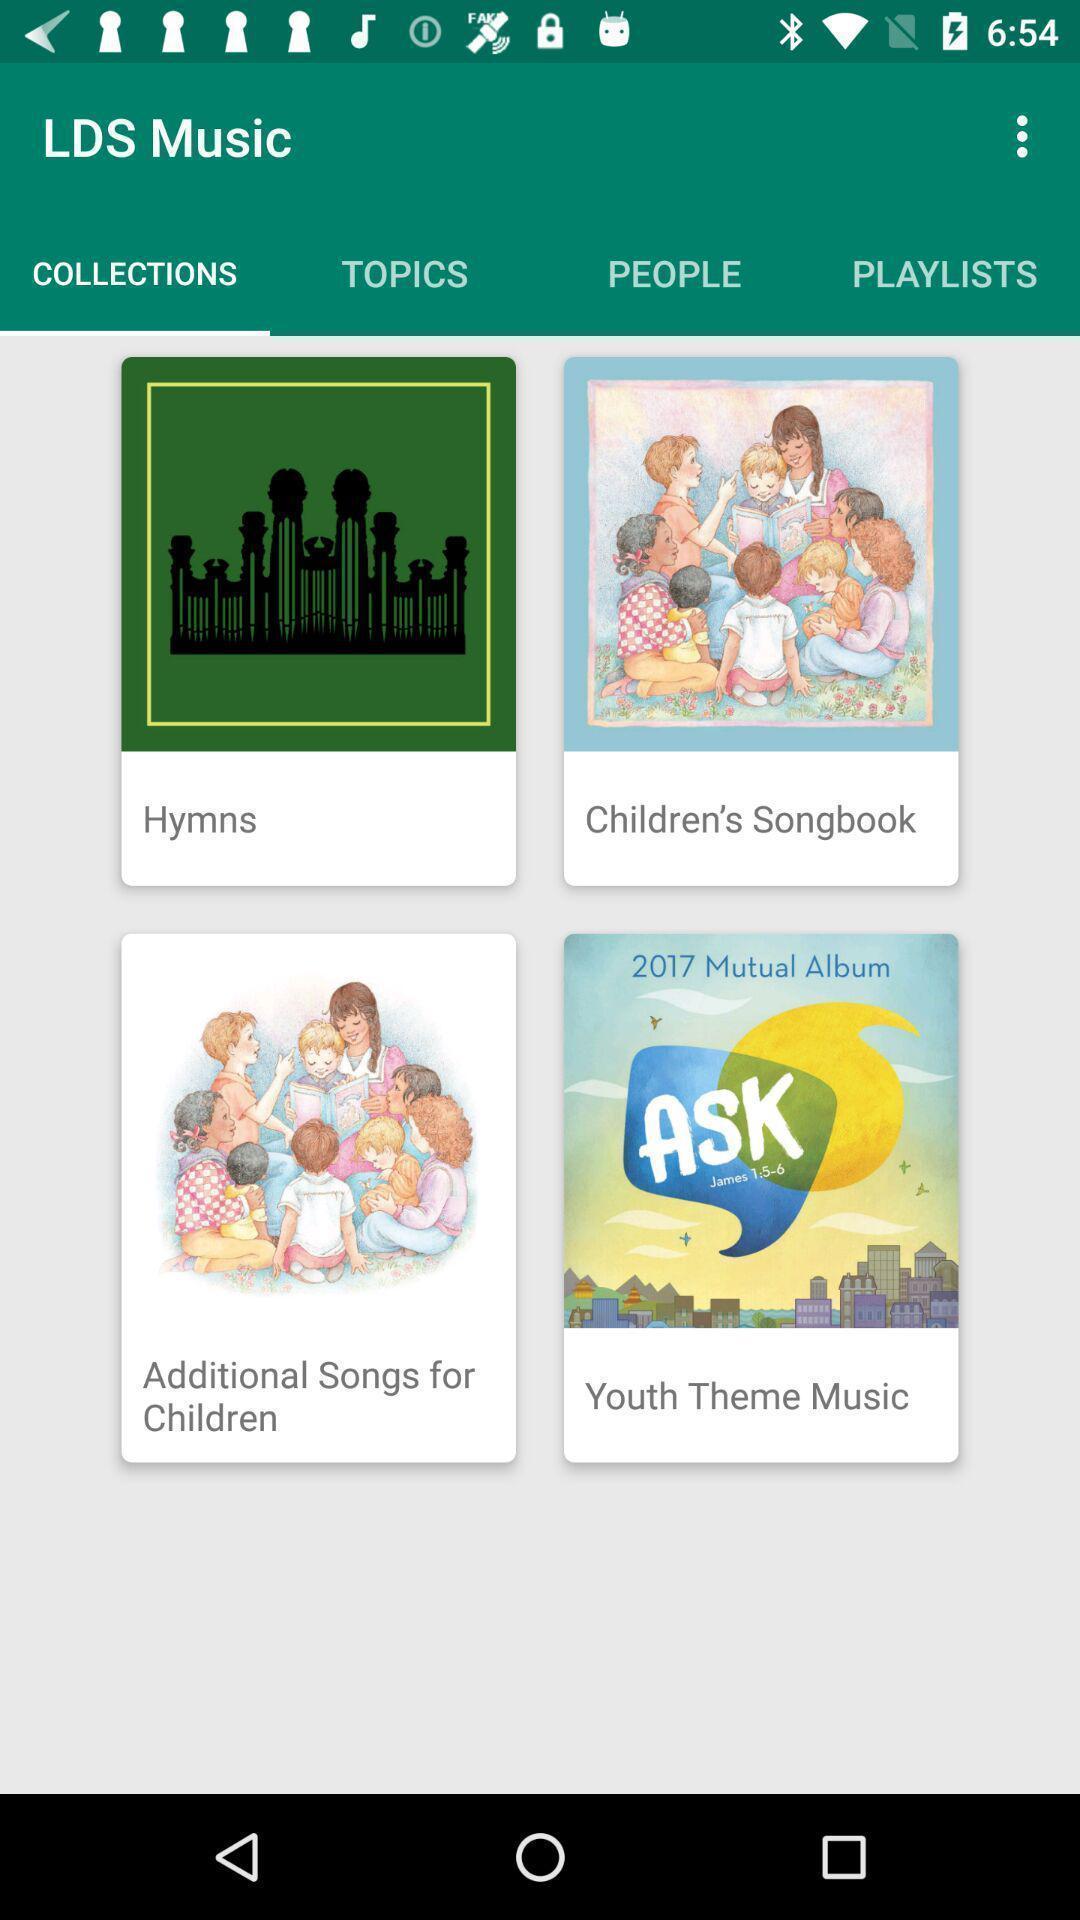Please provide a description for this image. Results for collections in an music application. 